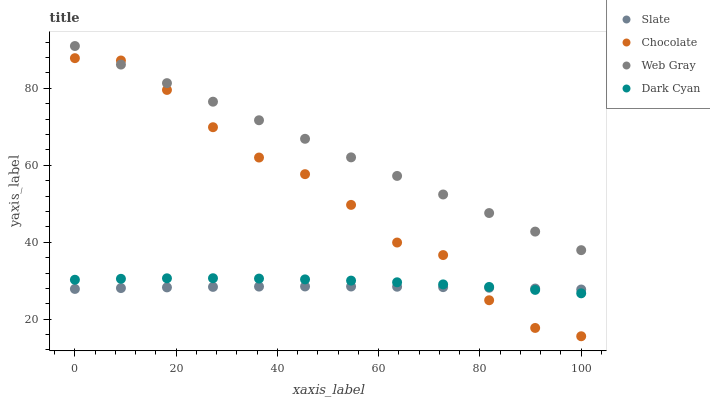Does Slate have the minimum area under the curve?
Answer yes or no. Yes. Does Web Gray have the maximum area under the curve?
Answer yes or no. Yes. Does Web Gray have the minimum area under the curve?
Answer yes or no. No. Does Slate have the maximum area under the curve?
Answer yes or no. No. Is Web Gray the smoothest?
Answer yes or no. Yes. Is Chocolate the roughest?
Answer yes or no. Yes. Is Slate the smoothest?
Answer yes or no. No. Is Slate the roughest?
Answer yes or no. No. Does Chocolate have the lowest value?
Answer yes or no. Yes. Does Slate have the lowest value?
Answer yes or no. No. Does Web Gray have the highest value?
Answer yes or no. Yes. Does Slate have the highest value?
Answer yes or no. No. Is Slate less than Web Gray?
Answer yes or no. Yes. Is Web Gray greater than Dark Cyan?
Answer yes or no. Yes. Does Chocolate intersect Dark Cyan?
Answer yes or no. Yes. Is Chocolate less than Dark Cyan?
Answer yes or no. No. Is Chocolate greater than Dark Cyan?
Answer yes or no. No. Does Slate intersect Web Gray?
Answer yes or no. No. 